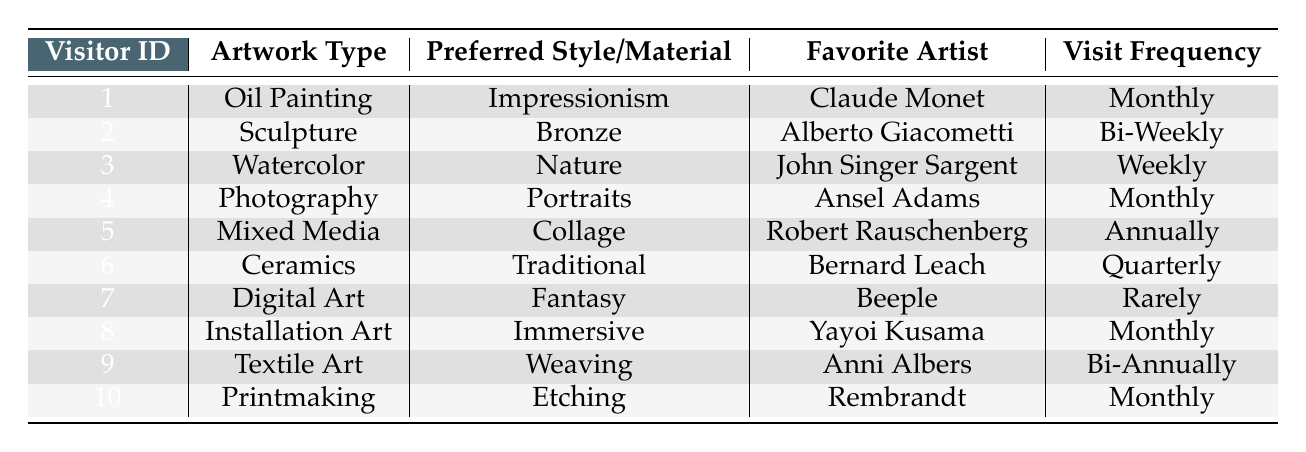What type of artwork does Visitor 1 prefer? Visitor 1's row shows that they prefer "Oil Painting" as their artwork type.
Answer: Oil Painting How often does Visitor 6 visit exhibitions? Looking at Visitor 6's details, their exhibition visit frequency is "Quarterly."
Answer: Quarterly Which favorite artist is associated with Watercolor? In the row for Visitor 3, it is stated that their favorite artist is "John Singer Sargent" for the artwork type "Watercolor."
Answer: John Singer Sargent Is there any visitor who prefers Digital Art? Yes, according to Visitor 7's row, they indeed prefer "Digital Art."
Answer: Yes How many visitors prefer artwork types that involve a 'nature' theme? Only Visitor 3 is noted for preferring a theme related to 'nature,' which makes the total count 1.
Answer: 1 What is the most common exhibition visit frequency among the visitors? Analyzing the visit frequency, "Monthly" is mentioned 5 times across different visitors.
Answer: Monthly Does Visitor 9 prefer Textile Art? Yes, the data shows Visitor 9 has chosen "Textile Art" as their artwork type.
Answer: Yes Which artwork type does the visitor with the least frequent exhibition visits prefer? Visitor 7, who visits exhibitions rarely, prefers "Digital Art."
Answer: Digital Art What is the average exhibition visit frequency of all visitors in months? The frequencies are: Monthly (5), Bi-Weekly (2), Weekly (1), Quarterly (1), Annually (1), and Bi-Annually (0.5). Converting them to numerical counts gives a total of 10.5 visits for 10 visitors, leading to an average of 1.05 months per visit.
Answer: 1.05 How many visitors have "Impressionism" as their preferred style? Only Visitor 1 has "Impressionism" as their preferred style, so the total number is one visitor.
Answer: 1 